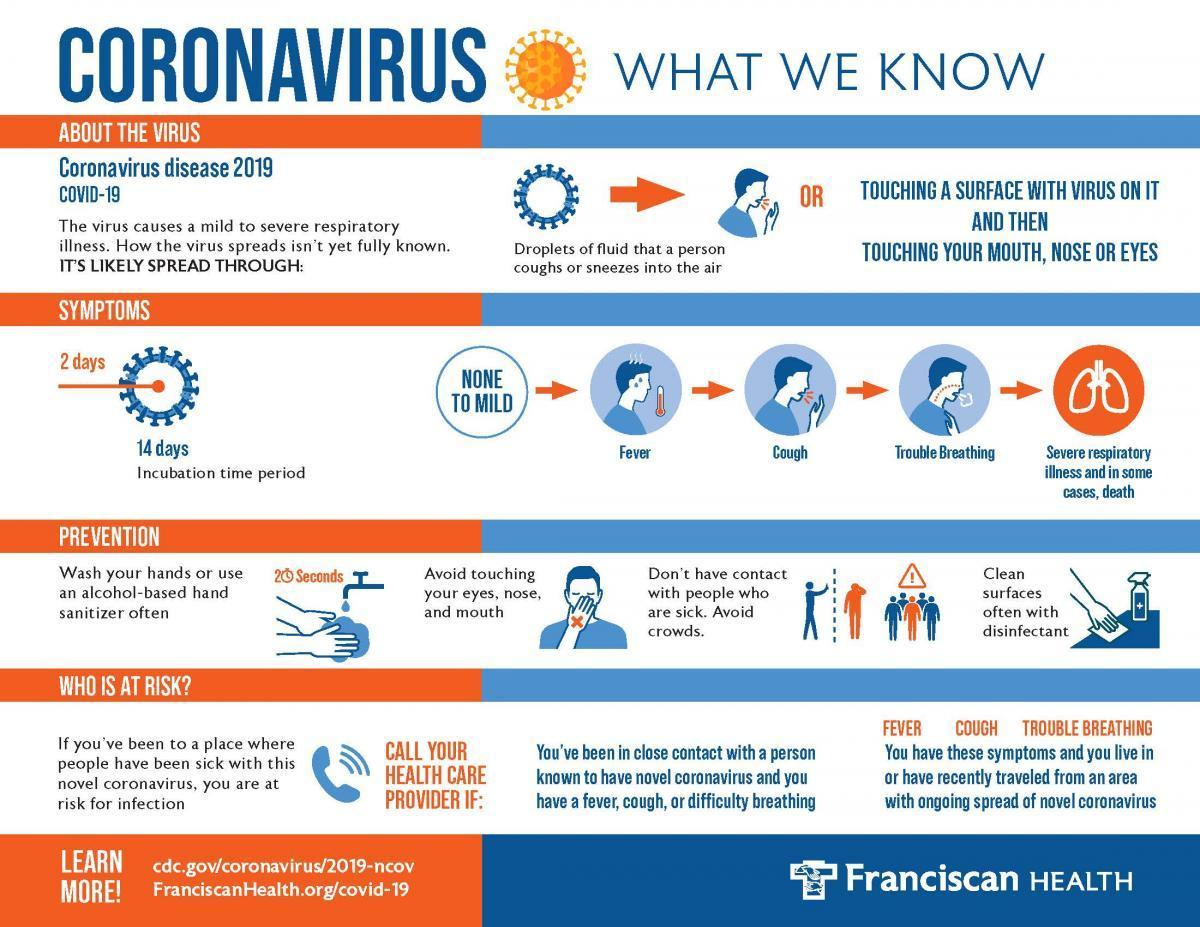What is a recommended type of sanitizer for sanitizing your hands?
Answer the question with a short phrase. Alcohol-based hand sanitizer What should you do if you are at risk of infection? Call your health care provider What can be used to clean the surfaces? Disinfectant For how long should you wash your hands? 20 seconds What are the first three symptoms shown? Fever, cough, trouble breathing Which are the three parts of your face you shouldn't touch? Eyes, nose, and mouth 